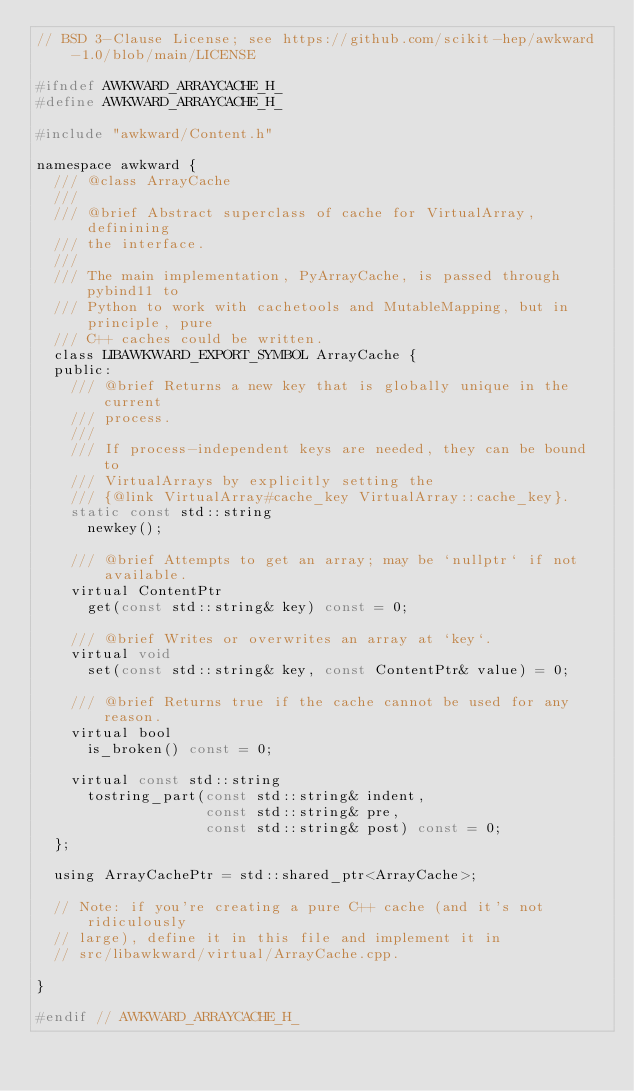<code> <loc_0><loc_0><loc_500><loc_500><_C_>// BSD 3-Clause License; see https://github.com/scikit-hep/awkward-1.0/blob/main/LICENSE

#ifndef AWKWARD_ARRAYCACHE_H_
#define AWKWARD_ARRAYCACHE_H_

#include "awkward/Content.h"

namespace awkward {
  /// @class ArrayCache
  ///
  /// @brief Abstract superclass of cache for VirtualArray, definining
  /// the interface.
  ///
  /// The main implementation, PyArrayCache, is passed through pybind11 to
  /// Python to work with cachetools and MutableMapping, but in principle, pure
  /// C++ caches could be written.
  class LIBAWKWARD_EXPORT_SYMBOL ArrayCache {
  public:
    /// @brief Returns a new key that is globally unique in the current
    /// process.
    ///
    /// If process-independent keys are needed, they can be bound to
    /// VirtualArrays by explicitly setting the
    /// {@link VirtualArray#cache_key VirtualArray::cache_key}.
    static const std::string
      newkey();

    /// @brief Attempts to get an array; may be `nullptr` if not available.
    virtual ContentPtr
      get(const std::string& key) const = 0;

    /// @brief Writes or overwrites an array at `key`.
    virtual void
      set(const std::string& key, const ContentPtr& value) = 0;

    /// @brief Returns true if the cache cannot be used for any reason.
    virtual bool
      is_broken() const = 0;

    virtual const std::string
      tostring_part(const std::string& indent,
                    const std::string& pre,
                    const std::string& post) const = 0;
  };

  using ArrayCachePtr = std::shared_ptr<ArrayCache>;

  // Note: if you're creating a pure C++ cache (and it's not ridiculously
  // large), define it in this file and implement it in
  // src/libawkward/virtual/ArrayCache.cpp.

}

#endif // AWKWARD_ARRAYCACHE_H_
</code> 